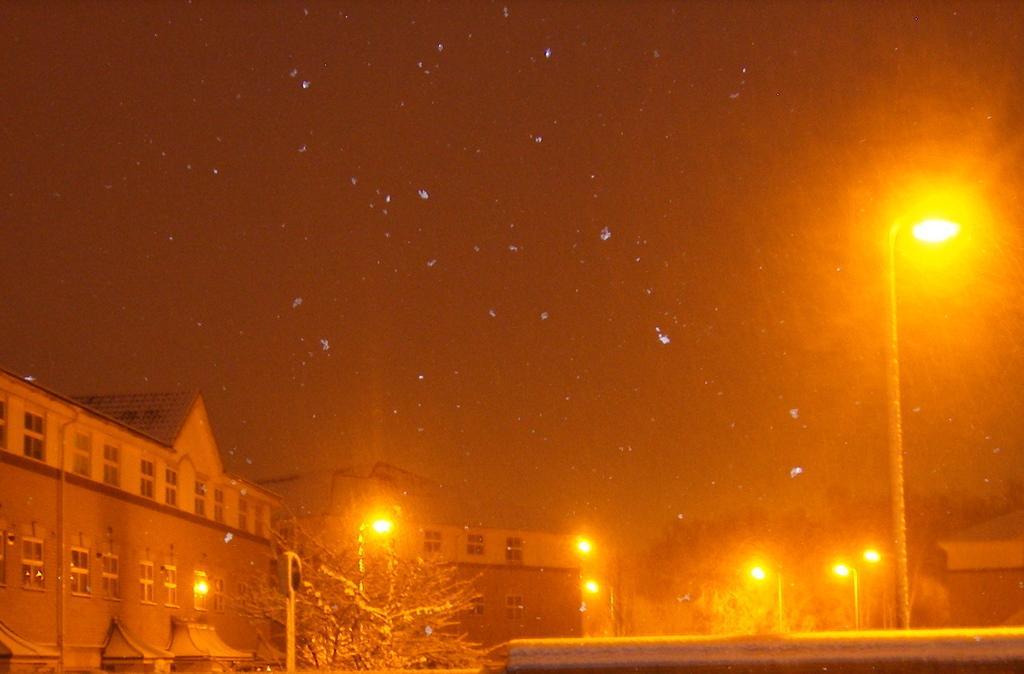How would you summarize this image in a sentence or two? There are some trees at the bottom of this image. There is a light pole on the right side of this image and there is a sky in the background. 